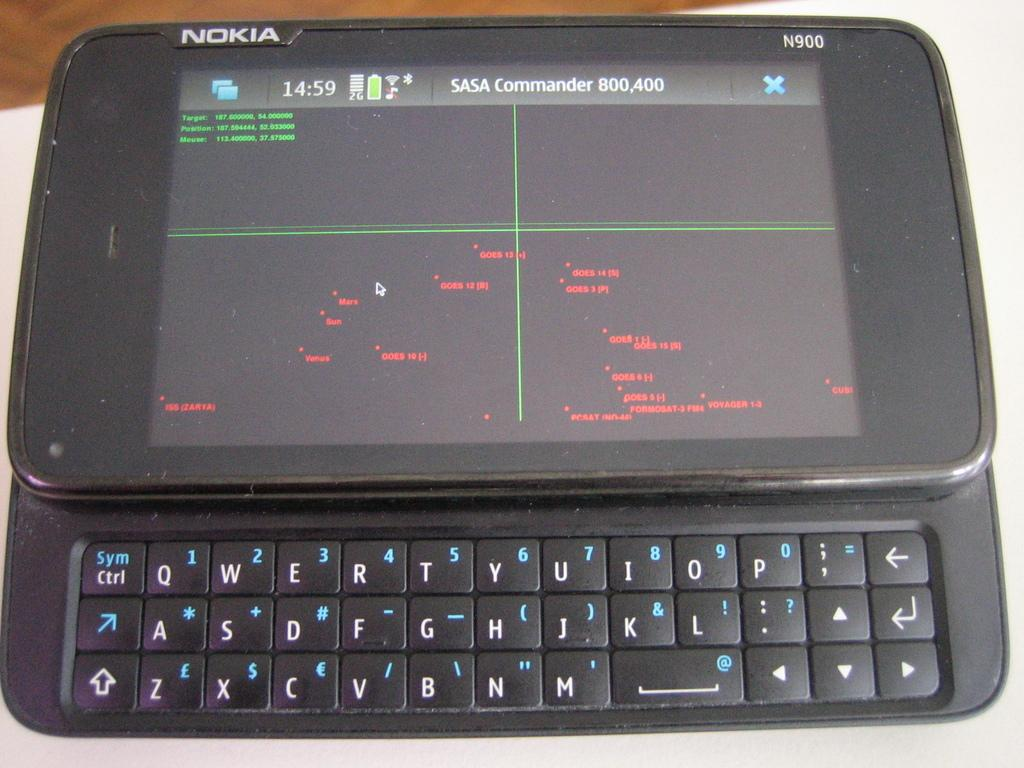<image>
Describe the image concisely. The Nokia phone with sliding keyboard can run the SASA Commander game. 